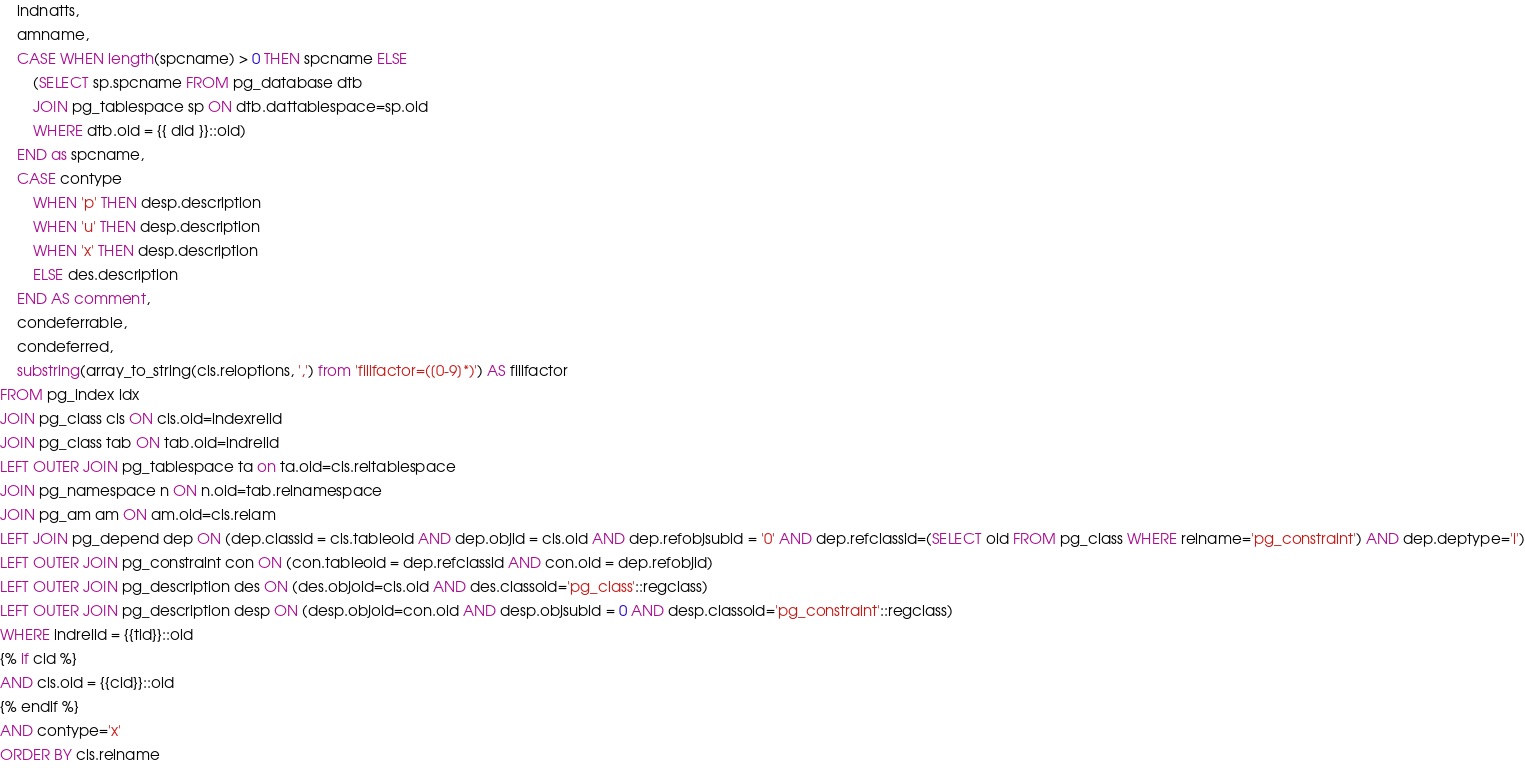<code> <loc_0><loc_0><loc_500><loc_500><_SQL_>    indnatts,
    amname,
    CASE WHEN length(spcname) > 0 THEN spcname ELSE
        (SELECT sp.spcname FROM pg_database dtb
        JOIN pg_tablespace sp ON dtb.dattablespace=sp.oid
        WHERE dtb.oid = {{ did }}::oid)
    END as spcname,
    CASE contype
        WHEN 'p' THEN desp.description
        WHEN 'u' THEN desp.description
        WHEN 'x' THEN desp.description
        ELSE des.description
    END AS comment,
    condeferrable,
    condeferred,
    substring(array_to_string(cls.reloptions, ',') from 'fillfactor=([0-9]*)') AS fillfactor
FROM pg_index idx
JOIN pg_class cls ON cls.oid=indexrelid
JOIN pg_class tab ON tab.oid=indrelid
LEFT OUTER JOIN pg_tablespace ta on ta.oid=cls.reltablespace
JOIN pg_namespace n ON n.oid=tab.relnamespace
JOIN pg_am am ON am.oid=cls.relam
LEFT JOIN pg_depend dep ON (dep.classid = cls.tableoid AND dep.objid = cls.oid AND dep.refobjsubid = '0' AND dep.refclassid=(SELECT oid FROM pg_class WHERE relname='pg_constraint') AND dep.deptype='i')
LEFT OUTER JOIN pg_constraint con ON (con.tableoid = dep.refclassid AND con.oid = dep.refobjid)
LEFT OUTER JOIN pg_description des ON (des.objoid=cls.oid AND des.classoid='pg_class'::regclass)
LEFT OUTER JOIN pg_description desp ON (desp.objoid=con.oid AND desp.objsubid = 0 AND desp.classoid='pg_constraint'::regclass)
WHERE indrelid = {{tid}}::oid
{% if cid %}
AND cls.oid = {{cid}}::oid
{% endif %}
AND contype='x'
ORDER BY cls.relname</code> 